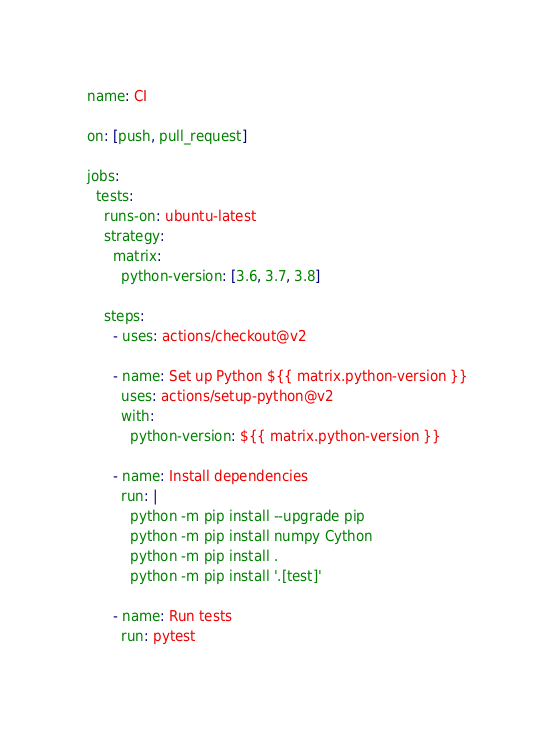<code> <loc_0><loc_0><loc_500><loc_500><_YAML_>name: CI

on: [push, pull_request]

jobs:
  tests:
    runs-on: ubuntu-latest
    strategy:
      matrix:
        python-version: [3.6, 3.7, 3.8]

    steps:
      - uses: actions/checkout@v2

      - name: Set up Python ${{ matrix.python-version }}
        uses: actions/setup-python@v2
        with:
          python-version: ${{ matrix.python-version }}

      - name: Install dependencies
        run: |
          python -m pip install --upgrade pip
          python -m pip install numpy Cython
          python -m pip install .
          python -m pip install '.[test]'

      - name: Run tests
        run: pytest
</code> 